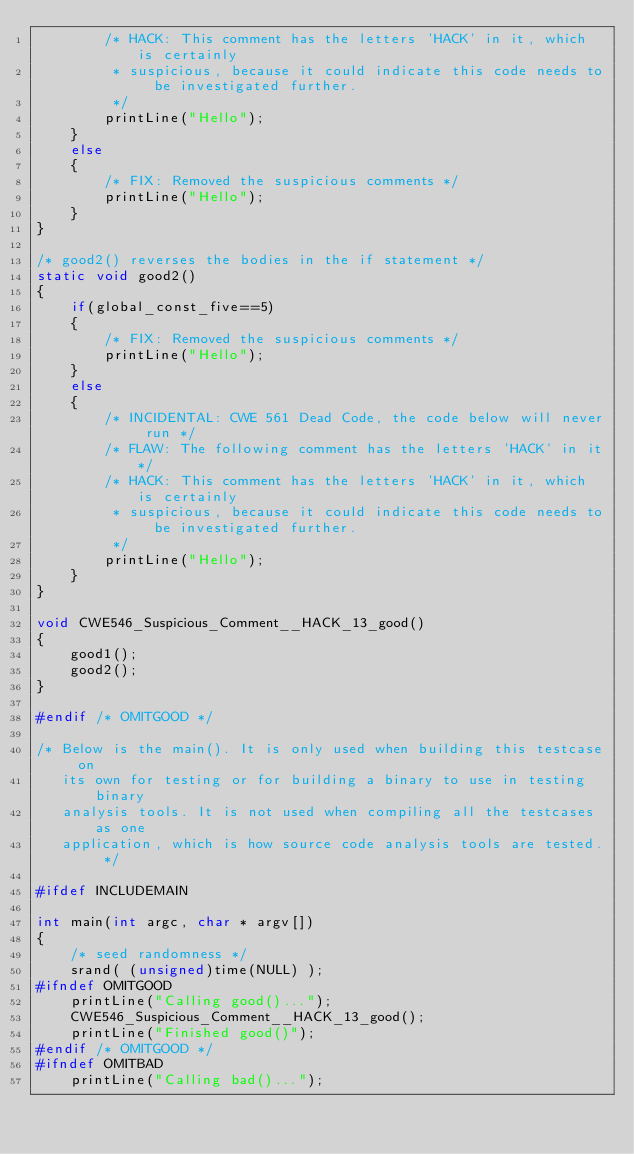Convert code to text. <code><loc_0><loc_0><loc_500><loc_500><_C_>        /* HACK: This comment has the letters 'HACK' in it, which is certainly
         * suspicious, because it could indicate this code needs to be investigated further.
         */
        printLine("Hello");
    }
    else
    {
        /* FIX: Removed the suspicious comments */
        printLine("Hello");
    }
}

/* good2() reverses the bodies in the if statement */
static void good2()
{
    if(global_const_five==5)
    {
        /* FIX: Removed the suspicious comments */
        printLine("Hello");
    }
    else
    {
        /* INCIDENTAL: CWE 561 Dead Code, the code below will never run */
        /* FLAW: The following comment has the letters 'HACK' in it*/
        /* HACK: This comment has the letters 'HACK' in it, which is certainly
         * suspicious, because it could indicate this code needs to be investigated further.
         */
        printLine("Hello");
    }
}

void CWE546_Suspicious_Comment__HACK_13_good()
{
    good1();
    good2();
}

#endif /* OMITGOOD */

/* Below is the main(). It is only used when building this testcase on
   its own for testing or for building a binary to use in testing binary
   analysis tools. It is not used when compiling all the testcases as one
   application, which is how source code analysis tools are tested. */

#ifdef INCLUDEMAIN

int main(int argc, char * argv[])
{
    /* seed randomness */
    srand( (unsigned)time(NULL) );
#ifndef OMITGOOD
    printLine("Calling good()...");
    CWE546_Suspicious_Comment__HACK_13_good();
    printLine("Finished good()");
#endif /* OMITGOOD */
#ifndef OMITBAD
    printLine("Calling bad()...");</code> 